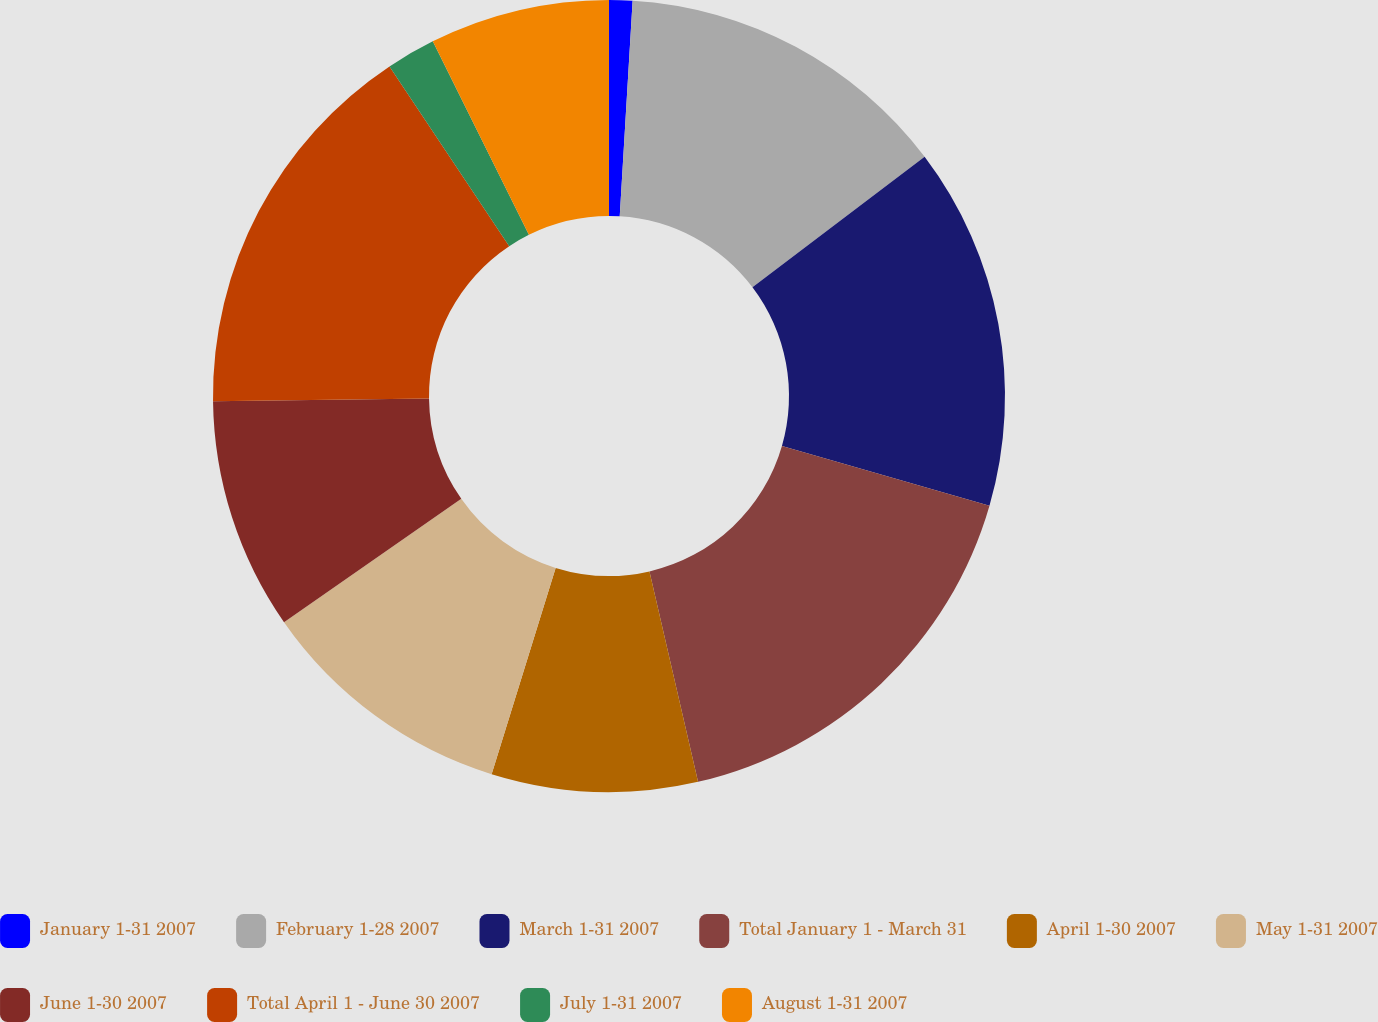Convert chart to OTSL. <chart><loc_0><loc_0><loc_500><loc_500><pie_chart><fcel>January 1-31 2007<fcel>February 1-28 2007<fcel>March 1-31 2007<fcel>Total January 1 - March 31<fcel>April 1-30 2007<fcel>May 1-31 2007<fcel>June 1-30 2007<fcel>Total April 1 - June 30 2007<fcel>July 1-31 2007<fcel>August 1-31 2007<nl><fcel>0.95%<fcel>13.73%<fcel>14.79%<fcel>16.92%<fcel>8.4%<fcel>10.53%<fcel>9.47%<fcel>15.86%<fcel>2.01%<fcel>7.34%<nl></chart> 